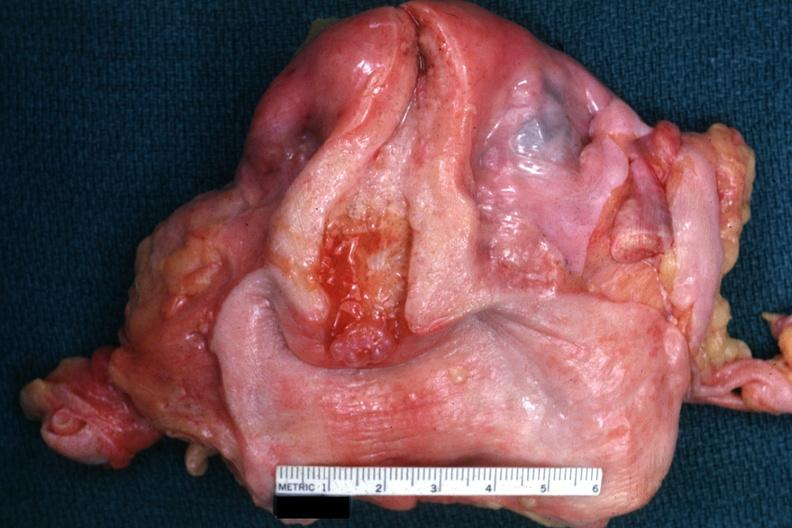what does this image show?
Answer the question using a single word or phrase. Excellent example with opened uterus and cervix and vagina 